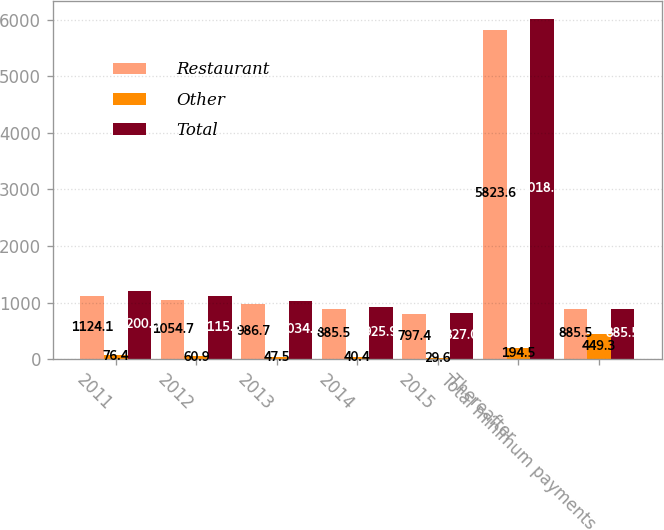<chart> <loc_0><loc_0><loc_500><loc_500><stacked_bar_chart><ecel><fcel>2011<fcel>2012<fcel>2013<fcel>2014<fcel>2015<fcel>Thereafter<fcel>Total minimum payments<nl><fcel>Restaurant<fcel>1124.1<fcel>1054.7<fcel>986.7<fcel>885.5<fcel>797.4<fcel>5823.6<fcel>885.5<nl><fcel>Other<fcel>76.4<fcel>60.9<fcel>47.5<fcel>40.4<fcel>29.6<fcel>194.5<fcel>449.3<nl><fcel>Total<fcel>1200.5<fcel>1115.6<fcel>1034.2<fcel>925.9<fcel>827<fcel>6018.1<fcel>885.5<nl></chart> 